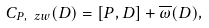<formula> <loc_0><loc_0><loc_500><loc_500>C _ { P , \ z w } ( D ) = [ P , D ] + \overline { \omega } ( D ) ,</formula> 